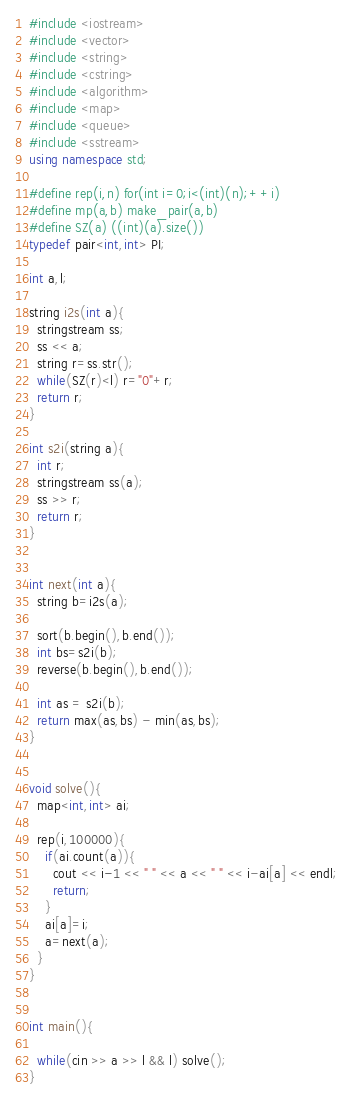Convert code to text. <code><loc_0><loc_0><loc_500><loc_500><_C++_>#include <iostream>
#include <vector>
#include <string>
#include <cstring>
#include <algorithm>
#include <map>
#include <queue>
#include <sstream>
using namespace std;

#define rep(i,n) for(int i=0;i<(int)(n);++i)
#define mp(a,b) make_pair(a,b)
#define SZ(a) ((int)(a).size())
typedef pair<int,int> PI;

int a,l;

string i2s(int a){
  stringstream ss;
  ss << a;
  string r=ss.str();
  while(SZ(r)<l) r="0"+r;
  return r;
}

int s2i(string a){
  int r;
  stringstream ss(a);
  ss >> r;
  return r;
}


int next(int a){
  string b=i2s(a);

  sort(b.begin(),b.end());
  int bs=s2i(b);
  reverse(b.begin(),b.end());  

  int as = s2i(b);
  return max(as,bs) - min(as,bs);
}


void solve(){
  map<int,int> ai;
  
  rep(i,100000){
    if(ai.count(a)){
      cout << i-1 << " " << a << " " << i-ai[a] << endl;
      return;
    }
    ai[a]=i;
    a=next(a);
  }
}


int main(){

  while(cin >> a >> l && l) solve();
}</code> 